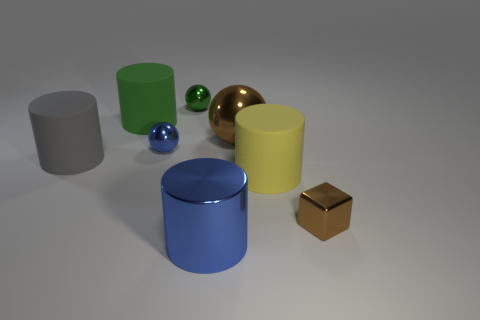How many other things are there of the same color as the metallic cylinder?
Your response must be concise. 1. Does the metallic sphere that is behind the green matte cylinder have the same size as the sphere that is right of the green metallic sphere?
Make the answer very short. No. There is a rubber cylinder right of the blue object that is on the right side of the small blue metal object; what size is it?
Ensure brevity in your answer.  Large. There is a cylinder that is both in front of the big gray object and behind the tiny brown metallic cube; what material is it made of?
Give a very brief answer. Rubber. What is the color of the metal cylinder?
Your answer should be very brief. Blue. Are there any other things that are the same material as the large ball?
Give a very brief answer. Yes. There is a big metallic object that is on the right side of the big metal cylinder; what is its shape?
Keep it short and to the point. Sphere. There is a rubber thing that is on the right side of the large thing in front of the tiny brown metallic object; are there any tiny blue balls behind it?
Make the answer very short. Yes. Is there any other thing that has the same shape as the large green matte object?
Provide a short and direct response. Yes. Is there a cyan matte thing?
Make the answer very short. No. 